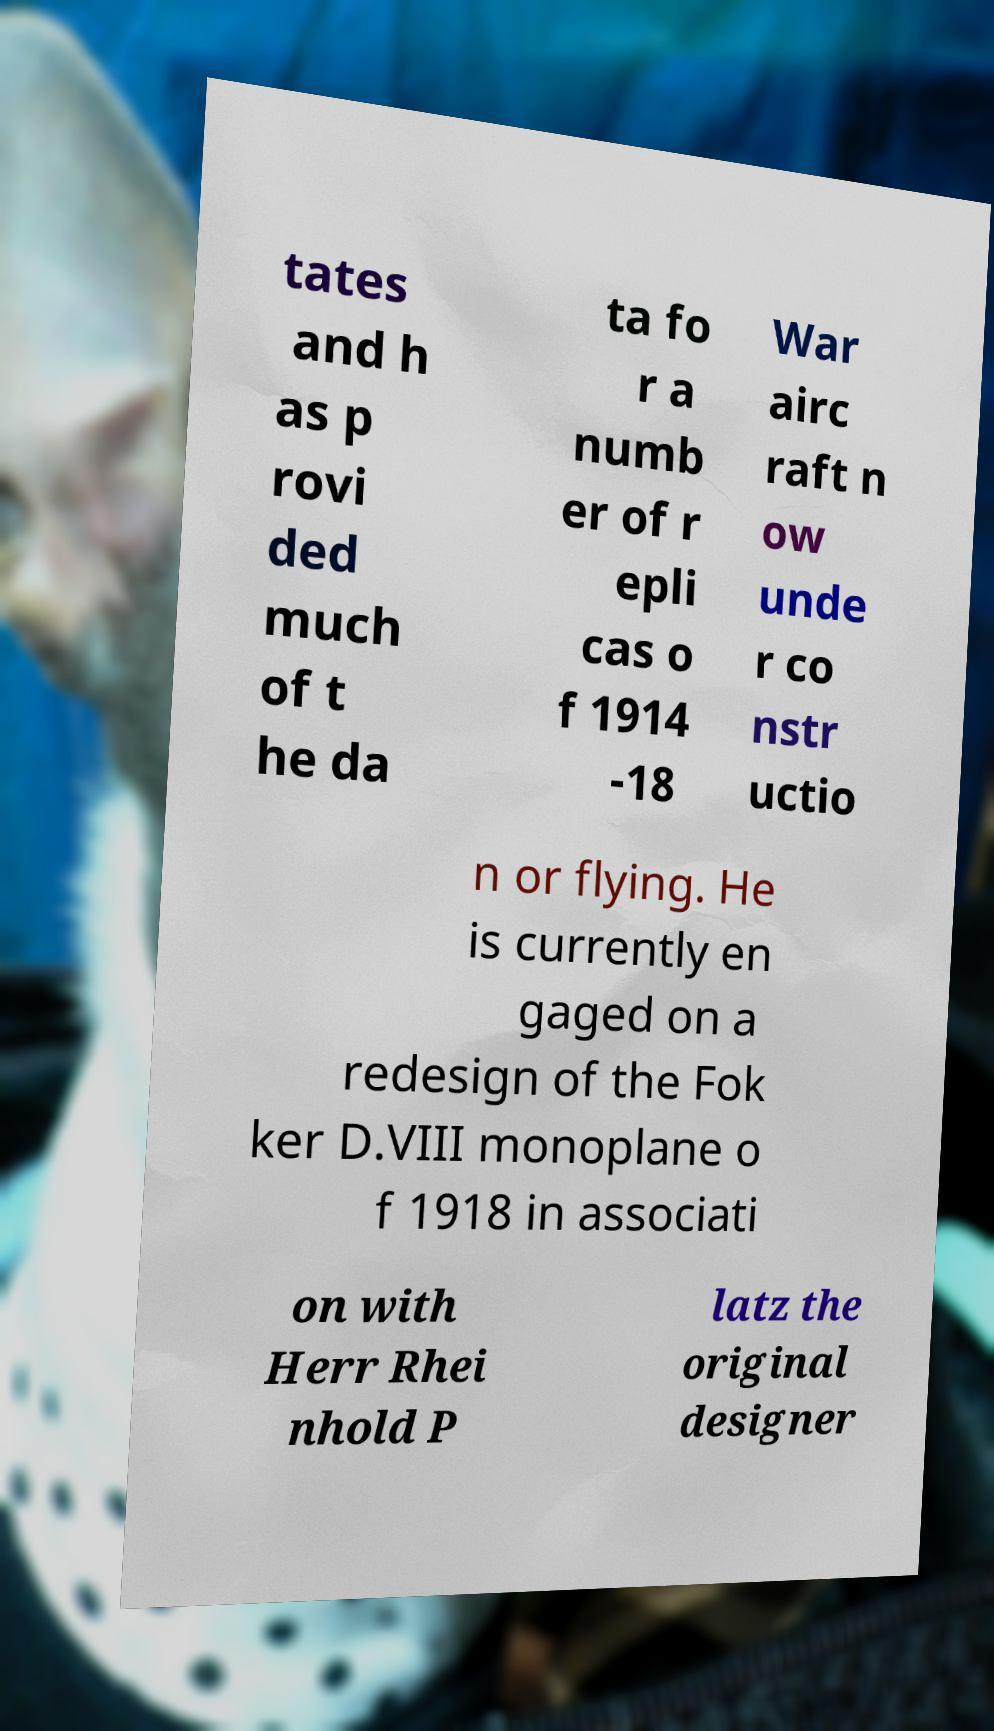Can you read and provide the text displayed in the image?This photo seems to have some interesting text. Can you extract and type it out for me? tates and h as p rovi ded much of t he da ta fo r a numb er of r epli cas o f 1914 -18 War airc raft n ow unde r co nstr uctio n or flying. He is currently en gaged on a redesign of the Fok ker D.VIII monoplane o f 1918 in associati on with Herr Rhei nhold P latz the original designer 